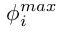Convert formula to latex. <formula><loc_0><loc_0><loc_500><loc_500>\phi _ { i } ^ { \max }</formula> 